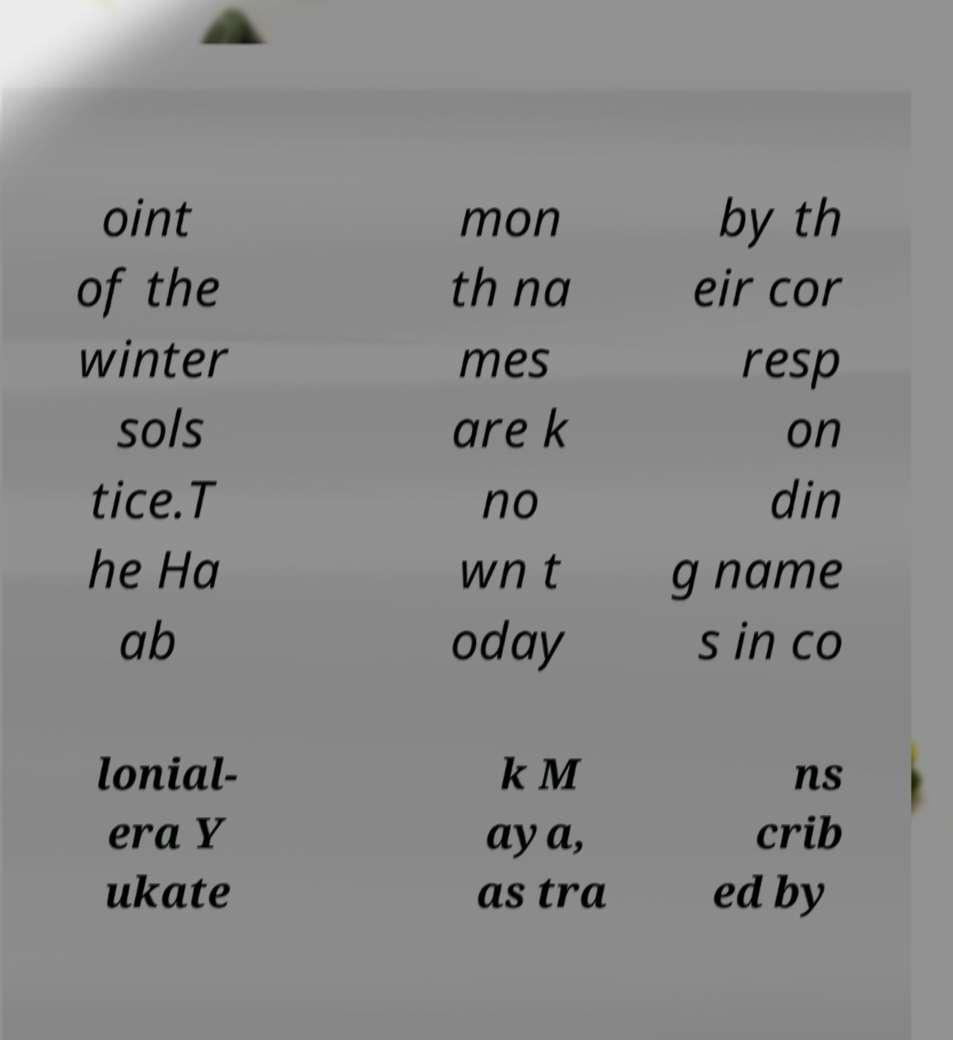Can you accurately transcribe the text from the provided image for me? oint of the winter sols tice.T he Ha ab mon th na mes are k no wn t oday by th eir cor resp on din g name s in co lonial- era Y ukate k M aya, as tra ns crib ed by 